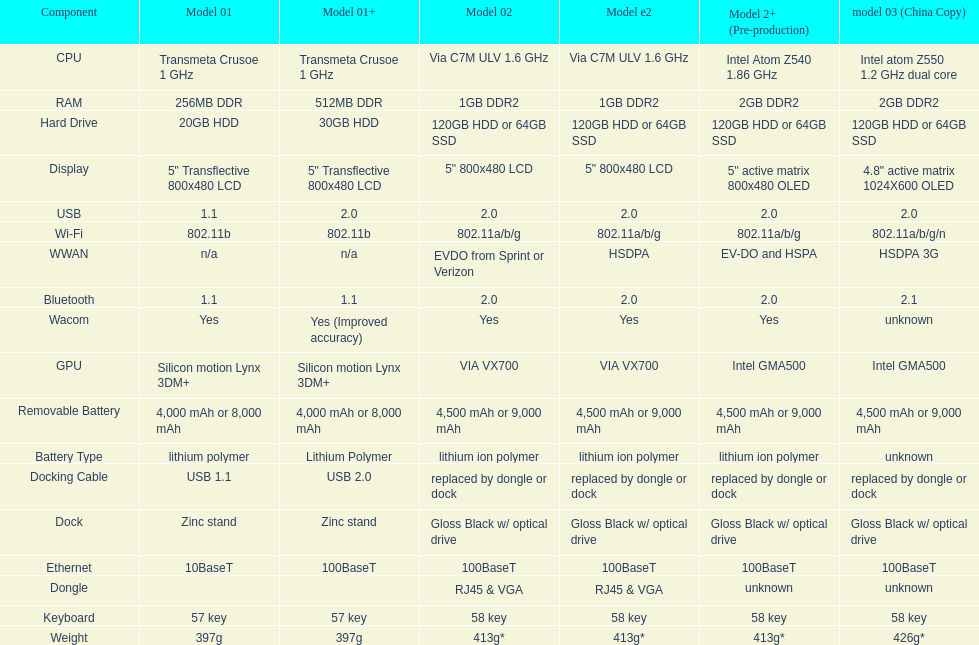How many models on average come with usb 5. 